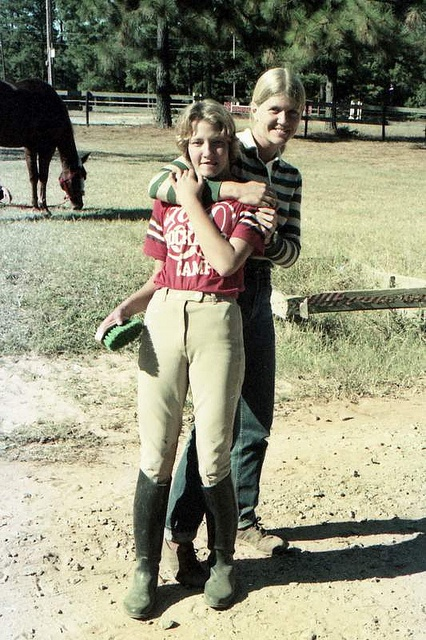Describe the objects in this image and their specific colors. I can see people in teal, beige, black, and gray tones, people in teal, black, gray, and beige tones, horse in teal, black, gray, darkgray, and maroon tones, bench in teal, black, gray, darkgray, and lightgray tones, and bench in teal, darkgray, black, and gray tones in this image. 